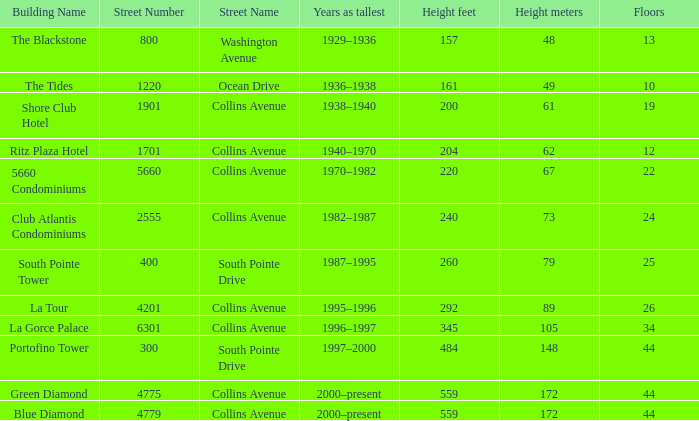How many floors does the Blue Diamond have? 44.0. 